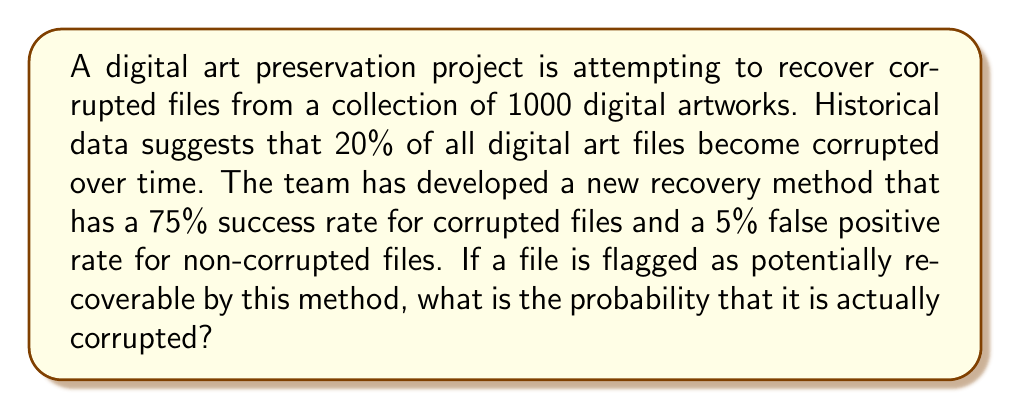Help me with this question. To solve this problem, we'll use Bayes' theorem, which is particularly relevant for a graduate student studying new methods of preserving digital art. Let's define our events:

A: The file is actually corrupted
B: The file is flagged as potentially recoverable

We're given the following probabilities:

P(A) = 0.20 (prior probability of corruption)
P(B|A) = 0.75 (true positive rate)
P(B|not A) = 0.05 (false positive rate)

We want to find P(A|B), which is the probability that a file is corrupted given that it's flagged as potentially recoverable.

Bayes' theorem states:

$$P(A|B) = \frac{P(B|A) \cdot P(A)}{P(B)}$$

We need to calculate P(B), which we can do using the law of total probability:

$$P(B) = P(B|A) \cdot P(A) + P(B|\text{not }A) \cdot P(\text{not }A)$$

$$P(B) = 0.75 \cdot 0.20 + 0.05 \cdot 0.80 = 0.15 + 0.04 = 0.19$$

Now we can apply Bayes' theorem:

$$P(A|B) = \frac{0.75 \cdot 0.20}{0.19} = \frac{0.15}{0.19} \approx 0.7895$$

Converting to a percentage, we get approximately 78.95%.
Answer: The probability that a file flagged as potentially recoverable is actually corrupted is approximately 78.95%. 